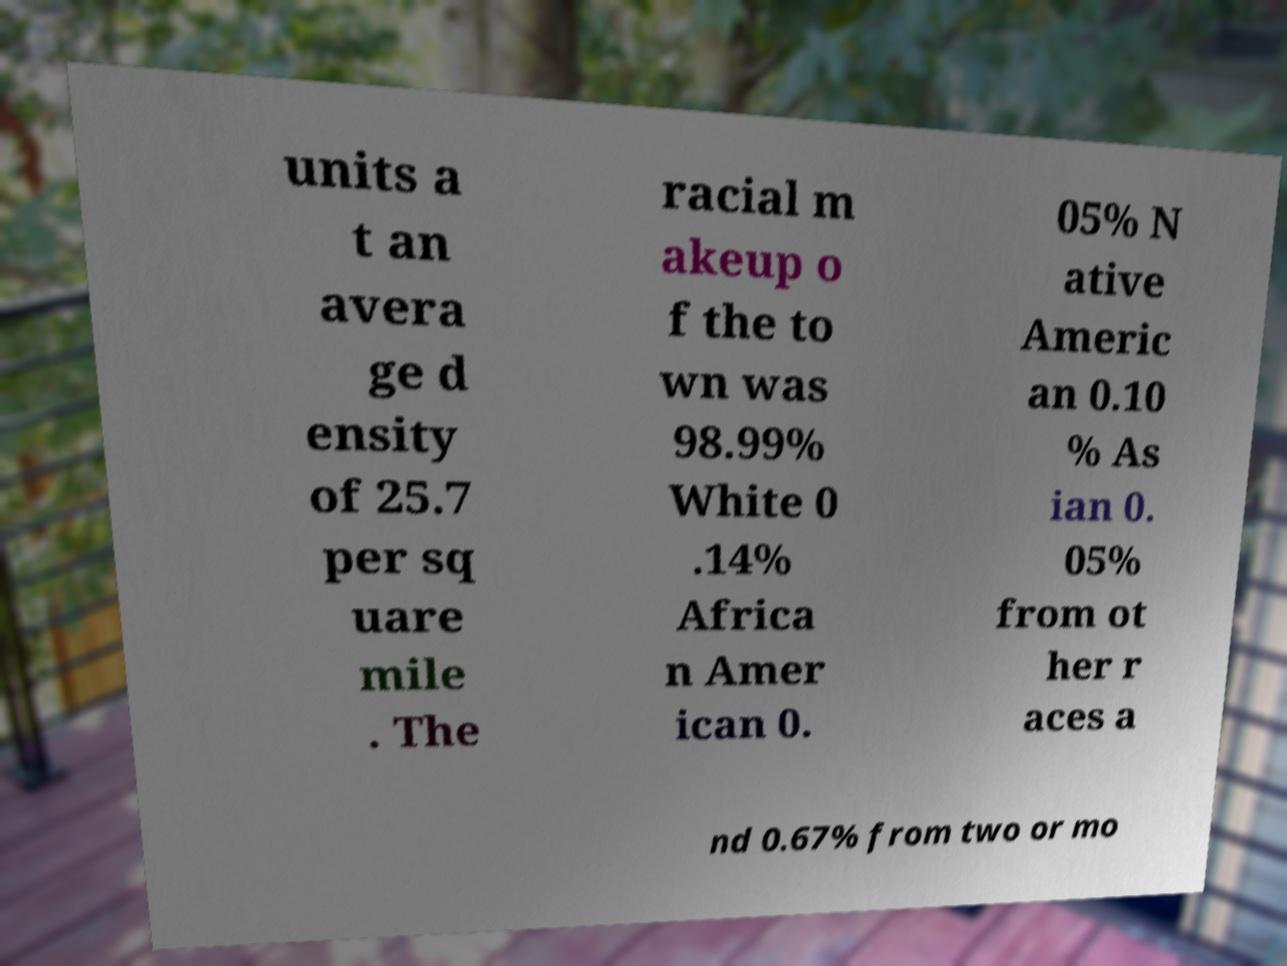Can you read and provide the text displayed in the image?This photo seems to have some interesting text. Can you extract and type it out for me? units a t an avera ge d ensity of 25.7 per sq uare mile . The racial m akeup o f the to wn was 98.99% White 0 .14% Africa n Amer ican 0. 05% N ative Americ an 0.10 % As ian 0. 05% from ot her r aces a nd 0.67% from two or mo 